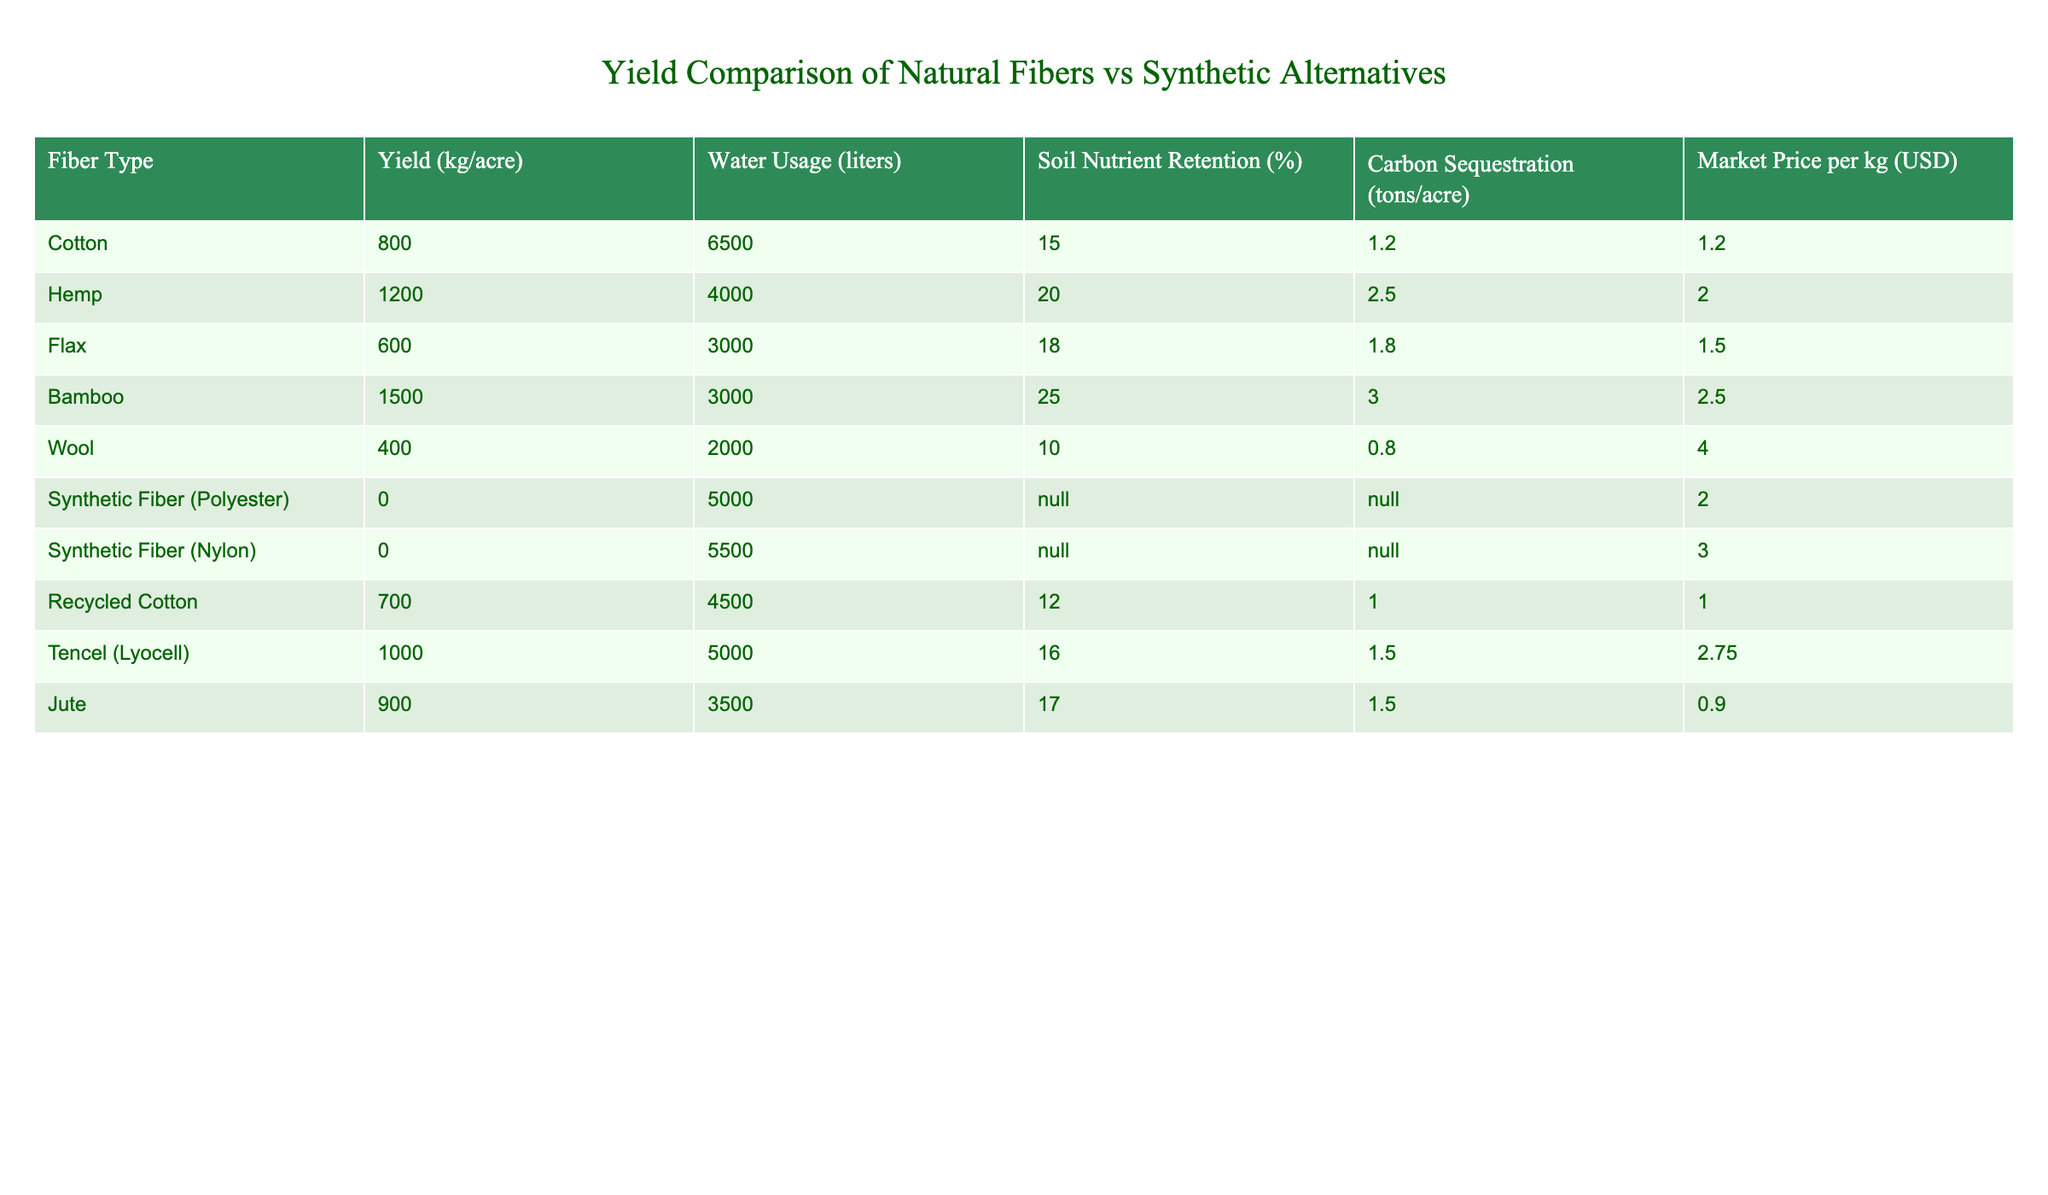What is the yield of hemp? The table lists the yield of different fiber types, and the yield for hemp specifically is indicated as 1200 kg/acre.
Answer: 1200 kg/acre Which fiber has the highest water usage? By examining the water usage values in the table, the highest is attributed to cotton, which has a usage of 6500 liters.
Answer: Cotton Is the soil nutrient retention for jute greater than for wool? Comparing the soil nutrient retention percentages in the table reveals that jute has 17% and wool has 10%, confirming jute’s higher retention.
Answer: Yes What is the average yield of all natural fibers listed in the table? The yield for the natural fibers are Cotton (800), Hemp (1200), Flax (600), Bamboo (1500), Wool (400), Jute (900). Summing these yields gives 800 + 1200 + 600 + 1500 + 400 + 900 = 4500 kg. Dividing by the number of natural fibers (6) results in 4500 / 6 = 750 kg/acre.
Answer: 750 kg/acre Do synthetic fibers have any yield? The table shows both synthetic fiber types (Polyester and Nylon), and their yield values are listed as 0 kg/acre, indicating that they do not produce any yield.
Answer: No What is the carbon sequestration for bamboo compared to that of flax? The carbon sequestration values are 3.0 tons/acre for bamboo and 1.8 tons/acre for flax. Comparing these values shows that bamboo has a higher amount of carbon sequestration than flax.
Answer: Bamboo has more carbon sequestration How much more water does cotton use compared to jute? The water usage for cotton is 6500 liters and for jute is 3500 liters. To find the difference, subtract the water usage of jute from cotton: 6500 - 3500 = 3000 liters.
Answer: 3000 liters Which fiber has the highest market price per kg? By reviewing the market price column, wool has the highest market price at 4.00 USD per kg, making it the most expensive fiber listed.
Answer: Wool What is the total carbon sequestration for all natural fibers? The individual carbon sequestration values for natural fibers are Cotton (1.2), Hemp (2.5), Flax (1.8), Bamboo (3.0), Wool (0.8), and Jute (1.5). Summing these yields gives 1.2 + 2.5 + 1.8 + 3.0 + 0.8 + 1.5 = 10.8 tons/acre for total carbon sequestration from all natural fiber types.
Answer: 10.8 tons/acre 